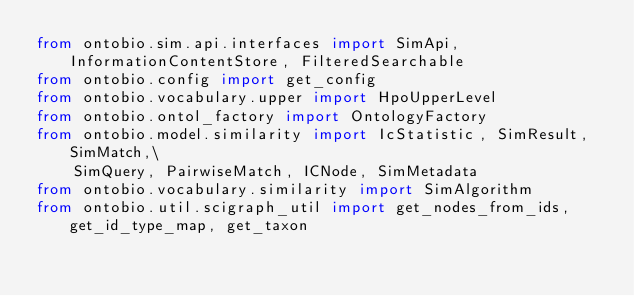Convert code to text. <code><loc_0><loc_0><loc_500><loc_500><_Python_>from ontobio.sim.api.interfaces import SimApi, InformationContentStore, FilteredSearchable
from ontobio.config import get_config
from ontobio.vocabulary.upper import HpoUpperLevel
from ontobio.ontol_factory import OntologyFactory
from ontobio.model.similarity import IcStatistic, SimResult, SimMatch,\
    SimQuery, PairwiseMatch, ICNode, SimMetadata
from ontobio.vocabulary.similarity import SimAlgorithm
from ontobio.util.scigraph_util import get_nodes_from_ids, get_id_type_map, get_taxon
</code> 